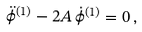Convert formula to latex. <formula><loc_0><loc_0><loc_500><loc_500>\ddot { \phi } ^ { ( 1 ) } - 2 A \, \dot { \phi } ^ { ( 1 ) } = 0 \, ,</formula> 